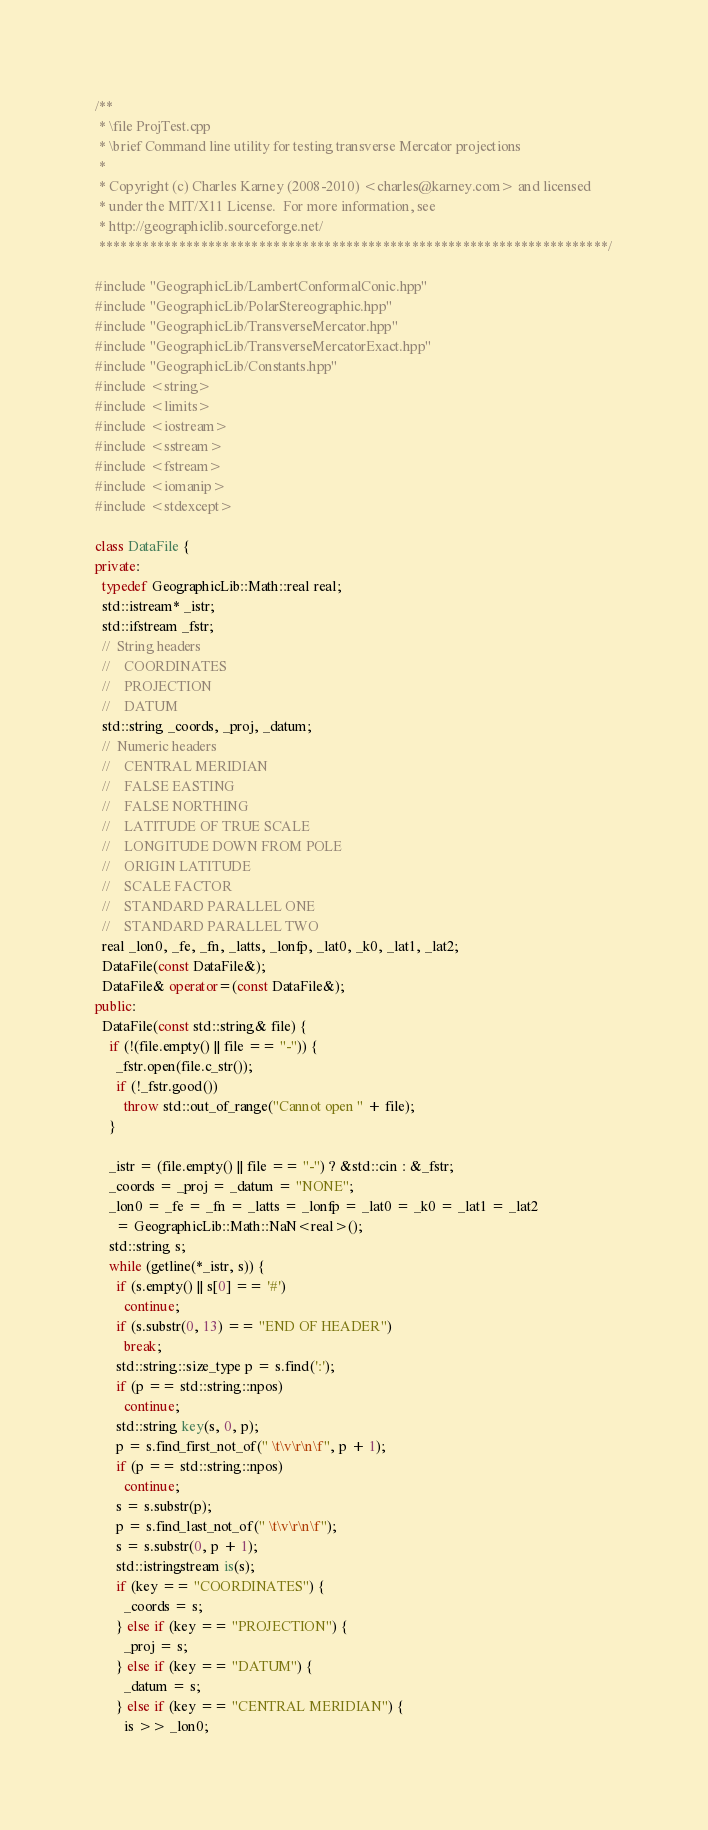Convert code to text. <code><loc_0><loc_0><loc_500><loc_500><_C++_>/**
 * \file ProjTest.cpp
 * \brief Command line utility for testing transverse Mercator projections
 *
 * Copyright (c) Charles Karney (2008-2010) <charles@karney.com> and licensed
 * under the MIT/X11 License.  For more information, see
 * http://geographiclib.sourceforge.net/
 **********************************************************************/

#include "GeographicLib/LambertConformalConic.hpp"
#include "GeographicLib/PolarStereographic.hpp"
#include "GeographicLib/TransverseMercator.hpp"
#include "GeographicLib/TransverseMercatorExact.hpp"
#include "GeographicLib/Constants.hpp"
#include <string>
#include <limits>
#include <iostream>
#include <sstream>
#include <fstream>
#include <iomanip>
#include <stdexcept>

class DataFile {
private:
  typedef GeographicLib::Math::real real;
  std::istream* _istr;
  std::ifstream _fstr;
  //  String headers
  //    COORDINATES
  //    PROJECTION
  //    DATUM
  std::string _coords, _proj, _datum;
  //  Numeric headers
  //    CENTRAL MERIDIAN
  //    FALSE EASTING
  //    FALSE NORTHING
  //    LATITUDE OF TRUE SCALE
  //    LONGITUDE DOWN FROM POLE
  //    ORIGIN LATITUDE
  //    SCALE FACTOR
  //    STANDARD PARALLEL ONE
  //    STANDARD PARALLEL TWO
  real _lon0, _fe, _fn, _latts, _lonfp, _lat0, _k0, _lat1, _lat2;
  DataFile(const DataFile&);
  DataFile& operator=(const DataFile&);
public:
  DataFile(const std::string& file) {
    if (!(file.empty() || file == "-")) {
      _fstr.open(file.c_str());
      if (!_fstr.good())
        throw std::out_of_range("Cannot open " + file);
    }

    _istr = (file.empty() || file == "-") ? &std::cin : &_fstr;
    _coords = _proj = _datum = "NONE";
    _lon0 = _fe = _fn = _latts = _lonfp = _lat0 = _k0 = _lat1 = _lat2
      = GeographicLib::Math::NaN<real>();
    std::string s;
    while (getline(*_istr, s)) {
      if (s.empty() || s[0] == '#')
        continue;
      if (s.substr(0, 13) == "END OF HEADER")
        break;
      std::string::size_type p = s.find(':');
      if (p == std::string::npos)
        continue;
      std::string key(s, 0, p);
      p = s.find_first_not_of(" \t\v\r\n\f", p + 1);
      if (p == std::string::npos)
        continue;
      s = s.substr(p);
      p = s.find_last_not_of(" \t\v\r\n\f");
      s = s.substr(0, p + 1);
      std::istringstream is(s);
      if (key == "COORDINATES") {
        _coords = s;
      } else if (key == "PROJECTION") {
        _proj = s;
      } else if (key == "DATUM") {
        _datum = s;
      } else if (key == "CENTRAL MERIDIAN") {
        is >> _lon0;</code> 